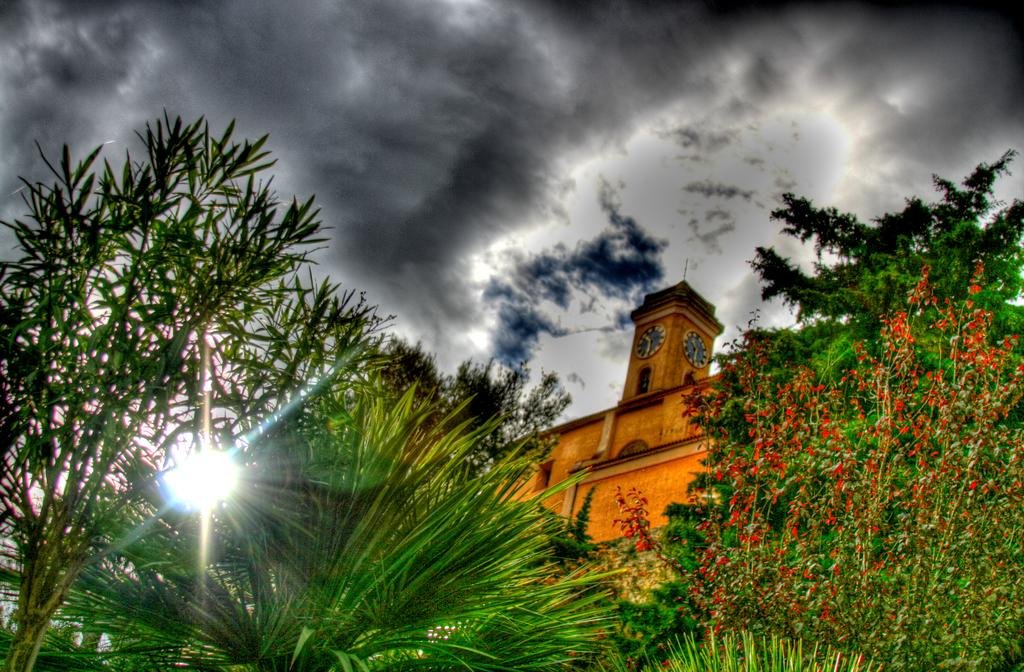What type of vegetation is at the bottom of the image? There are trees at the bottom of the image. What structure is located in the center of the image? There is a building in the center of the image. What is visible at the top of the image? The sky is visible at the top of the image. What color is the pen being used by the manager in the image? There is no pen or manager present in the image. What shape is the square in the image? There is no square present in the image. 